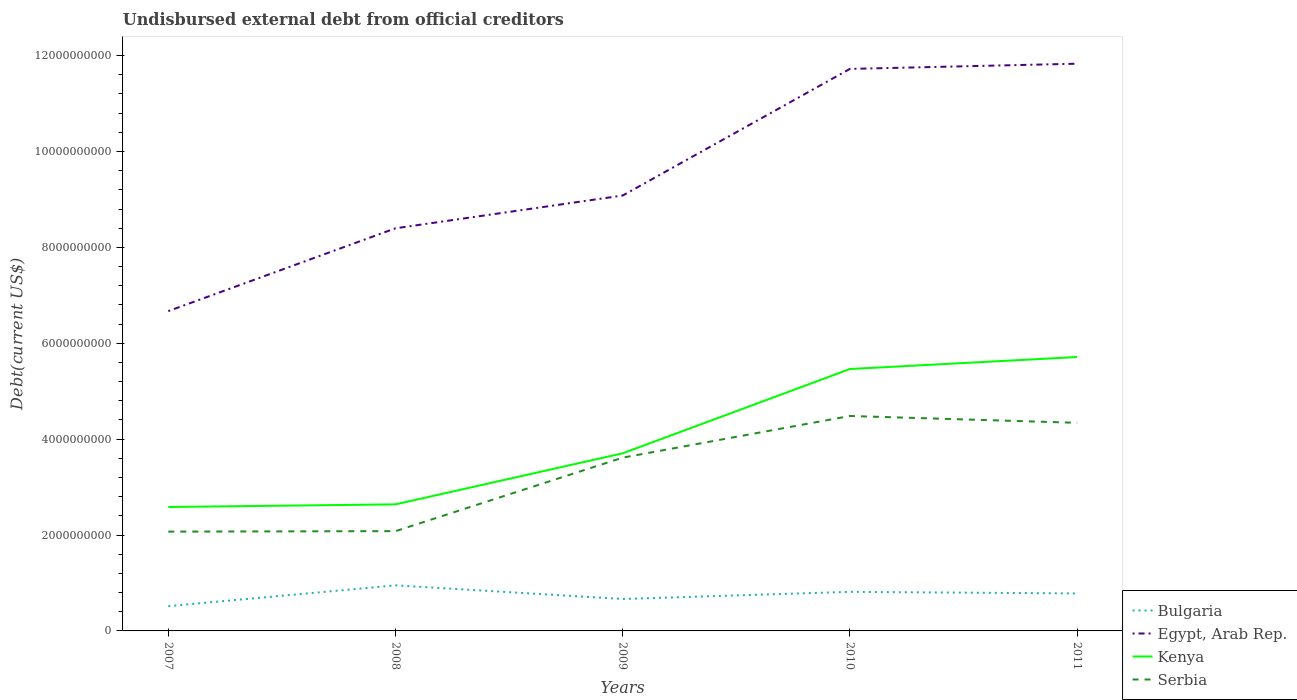Across all years, what is the maximum total debt in Egypt, Arab Rep.?
Keep it short and to the point. 6.67e+09. What is the total total debt in Bulgaria in the graph?
Keep it short and to the point. -2.65e+08. What is the difference between the highest and the second highest total debt in Bulgaria?
Offer a very short reply. 4.34e+08. How many lines are there?
Keep it short and to the point. 4. How many years are there in the graph?
Provide a succinct answer. 5. What is the difference between two consecutive major ticks on the Y-axis?
Provide a short and direct response. 2.00e+09. Does the graph contain grids?
Offer a very short reply. No. How many legend labels are there?
Make the answer very short. 4. What is the title of the graph?
Ensure brevity in your answer.  Undisbursed external debt from official creditors. Does "Afghanistan" appear as one of the legend labels in the graph?
Offer a terse response. No. What is the label or title of the X-axis?
Keep it short and to the point. Years. What is the label or title of the Y-axis?
Ensure brevity in your answer.  Debt(current US$). What is the Debt(current US$) of Bulgaria in 2007?
Give a very brief answer. 5.17e+08. What is the Debt(current US$) of Egypt, Arab Rep. in 2007?
Your answer should be very brief. 6.67e+09. What is the Debt(current US$) in Kenya in 2007?
Your answer should be compact. 2.58e+09. What is the Debt(current US$) in Serbia in 2007?
Make the answer very short. 2.07e+09. What is the Debt(current US$) in Bulgaria in 2008?
Your answer should be compact. 9.51e+08. What is the Debt(current US$) of Egypt, Arab Rep. in 2008?
Provide a short and direct response. 8.40e+09. What is the Debt(current US$) of Kenya in 2008?
Offer a very short reply. 2.64e+09. What is the Debt(current US$) in Serbia in 2008?
Ensure brevity in your answer.  2.08e+09. What is the Debt(current US$) of Bulgaria in 2009?
Provide a succinct answer. 6.66e+08. What is the Debt(current US$) in Egypt, Arab Rep. in 2009?
Ensure brevity in your answer.  9.08e+09. What is the Debt(current US$) of Kenya in 2009?
Keep it short and to the point. 3.70e+09. What is the Debt(current US$) in Serbia in 2009?
Offer a very short reply. 3.61e+09. What is the Debt(current US$) in Bulgaria in 2010?
Your answer should be very brief. 8.15e+08. What is the Debt(current US$) in Egypt, Arab Rep. in 2010?
Your answer should be compact. 1.17e+1. What is the Debt(current US$) in Kenya in 2010?
Your response must be concise. 5.46e+09. What is the Debt(current US$) of Serbia in 2010?
Ensure brevity in your answer.  4.48e+09. What is the Debt(current US$) in Bulgaria in 2011?
Make the answer very short. 7.82e+08. What is the Debt(current US$) of Egypt, Arab Rep. in 2011?
Give a very brief answer. 1.18e+1. What is the Debt(current US$) of Kenya in 2011?
Offer a very short reply. 5.71e+09. What is the Debt(current US$) in Serbia in 2011?
Your answer should be very brief. 4.34e+09. Across all years, what is the maximum Debt(current US$) of Bulgaria?
Offer a terse response. 9.51e+08. Across all years, what is the maximum Debt(current US$) in Egypt, Arab Rep.?
Your response must be concise. 1.18e+1. Across all years, what is the maximum Debt(current US$) in Kenya?
Your answer should be very brief. 5.71e+09. Across all years, what is the maximum Debt(current US$) of Serbia?
Give a very brief answer. 4.48e+09. Across all years, what is the minimum Debt(current US$) in Bulgaria?
Ensure brevity in your answer.  5.17e+08. Across all years, what is the minimum Debt(current US$) in Egypt, Arab Rep.?
Make the answer very short. 6.67e+09. Across all years, what is the minimum Debt(current US$) of Kenya?
Give a very brief answer. 2.58e+09. Across all years, what is the minimum Debt(current US$) in Serbia?
Give a very brief answer. 2.07e+09. What is the total Debt(current US$) in Bulgaria in the graph?
Provide a succinct answer. 3.73e+09. What is the total Debt(current US$) in Egypt, Arab Rep. in the graph?
Ensure brevity in your answer.  4.77e+1. What is the total Debt(current US$) of Kenya in the graph?
Your response must be concise. 2.01e+1. What is the total Debt(current US$) of Serbia in the graph?
Your answer should be compact. 1.66e+1. What is the difference between the Debt(current US$) of Bulgaria in 2007 and that in 2008?
Provide a succinct answer. -4.34e+08. What is the difference between the Debt(current US$) of Egypt, Arab Rep. in 2007 and that in 2008?
Ensure brevity in your answer.  -1.73e+09. What is the difference between the Debt(current US$) of Kenya in 2007 and that in 2008?
Provide a succinct answer. -5.50e+07. What is the difference between the Debt(current US$) in Serbia in 2007 and that in 2008?
Give a very brief answer. -1.02e+07. What is the difference between the Debt(current US$) of Bulgaria in 2007 and that in 2009?
Give a very brief answer. -1.49e+08. What is the difference between the Debt(current US$) in Egypt, Arab Rep. in 2007 and that in 2009?
Provide a short and direct response. -2.41e+09. What is the difference between the Debt(current US$) in Kenya in 2007 and that in 2009?
Keep it short and to the point. -1.12e+09. What is the difference between the Debt(current US$) in Serbia in 2007 and that in 2009?
Your answer should be compact. -1.54e+09. What is the difference between the Debt(current US$) in Bulgaria in 2007 and that in 2010?
Offer a terse response. -2.98e+08. What is the difference between the Debt(current US$) in Egypt, Arab Rep. in 2007 and that in 2010?
Keep it short and to the point. -5.05e+09. What is the difference between the Debt(current US$) of Kenya in 2007 and that in 2010?
Make the answer very short. -2.88e+09. What is the difference between the Debt(current US$) in Serbia in 2007 and that in 2010?
Offer a terse response. -2.41e+09. What is the difference between the Debt(current US$) in Bulgaria in 2007 and that in 2011?
Give a very brief answer. -2.65e+08. What is the difference between the Debt(current US$) in Egypt, Arab Rep. in 2007 and that in 2011?
Your answer should be compact. -5.16e+09. What is the difference between the Debt(current US$) of Kenya in 2007 and that in 2011?
Give a very brief answer. -3.13e+09. What is the difference between the Debt(current US$) in Serbia in 2007 and that in 2011?
Keep it short and to the point. -2.27e+09. What is the difference between the Debt(current US$) in Bulgaria in 2008 and that in 2009?
Provide a succinct answer. 2.84e+08. What is the difference between the Debt(current US$) in Egypt, Arab Rep. in 2008 and that in 2009?
Give a very brief answer. -6.83e+08. What is the difference between the Debt(current US$) of Kenya in 2008 and that in 2009?
Make the answer very short. -1.06e+09. What is the difference between the Debt(current US$) in Serbia in 2008 and that in 2009?
Provide a succinct answer. -1.53e+09. What is the difference between the Debt(current US$) of Bulgaria in 2008 and that in 2010?
Offer a terse response. 1.35e+08. What is the difference between the Debt(current US$) in Egypt, Arab Rep. in 2008 and that in 2010?
Your answer should be very brief. -3.32e+09. What is the difference between the Debt(current US$) in Kenya in 2008 and that in 2010?
Offer a terse response. -2.82e+09. What is the difference between the Debt(current US$) in Serbia in 2008 and that in 2010?
Your answer should be very brief. -2.40e+09. What is the difference between the Debt(current US$) in Bulgaria in 2008 and that in 2011?
Your answer should be compact. 1.69e+08. What is the difference between the Debt(current US$) of Egypt, Arab Rep. in 2008 and that in 2011?
Keep it short and to the point. -3.43e+09. What is the difference between the Debt(current US$) of Kenya in 2008 and that in 2011?
Ensure brevity in your answer.  -3.07e+09. What is the difference between the Debt(current US$) in Serbia in 2008 and that in 2011?
Ensure brevity in your answer.  -2.26e+09. What is the difference between the Debt(current US$) of Bulgaria in 2009 and that in 2010?
Offer a very short reply. -1.49e+08. What is the difference between the Debt(current US$) of Egypt, Arab Rep. in 2009 and that in 2010?
Offer a terse response. -2.64e+09. What is the difference between the Debt(current US$) in Kenya in 2009 and that in 2010?
Give a very brief answer. -1.76e+09. What is the difference between the Debt(current US$) in Serbia in 2009 and that in 2010?
Your answer should be compact. -8.69e+08. What is the difference between the Debt(current US$) of Bulgaria in 2009 and that in 2011?
Keep it short and to the point. -1.16e+08. What is the difference between the Debt(current US$) in Egypt, Arab Rep. in 2009 and that in 2011?
Make the answer very short. -2.75e+09. What is the difference between the Debt(current US$) of Kenya in 2009 and that in 2011?
Provide a short and direct response. -2.01e+09. What is the difference between the Debt(current US$) in Serbia in 2009 and that in 2011?
Your answer should be compact. -7.26e+08. What is the difference between the Debt(current US$) of Bulgaria in 2010 and that in 2011?
Your answer should be very brief. 3.32e+07. What is the difference between the Debt(current US$) of Egypt, Arab Rep. in 2010 and that in 2011?
Your answer should be very brief. -1.09e+08. What is the difference between the Debt(current US$) in Kenya in 2010 and that in 2011?
Offer a very short reply. -2.50e+08. What is the difference between the Debt(current US$) in Serbia in 2010 and that in 2011?
Your answer should be very brief. 1.43e+08. What is the difference between the Debt(current US$) of Bulgaria in 2007 and the Debt(current US$) of Egypt, Arab Rep. in 2008?
Offer a terse response. -7.88e+09. What is the difference between the Debt(current US$) of Bulgaria in 2007 and the Debt(current US$) of Kenya in 2008?
Your response must be concise. -2.12e+09. What is the difference between the Debt(current US$) of Bulgaria in 2007 and the Debt(current US$) of Serbia in 2008?
Your answer should be very brief. -1.56e+09. What is the difference between the Debt(current US$) of Egypt, Arab Rep. in 2007 and the Debt(current US$) of Kenya in 2008?
Your answer should be compact. 4.03e+09. What is the difference between the Debt(current US$) in Egypt, Arab Rep. in 2007 and the Debt(current US$) in Serbia in 2008?
Provide a short and direct response. 4.59e+09. What is the difference between the Debt(current US$) of Kenya in 2007 and the Debt(current US$) of Serbia in 2008?
Ensure brevity in your answer.  5.04e+08. What is the difference between the Debt(current US$) of Bulgaria in 2007 and the Debt(current US$) of Egypt, Arab Rep. in 2009?
Your answer should be compact. -8.57e+09. What is the difference between the Debt(current US$) in Bulgaria in 2007 and the Debt(current US$) in Kenya in 2009?
Provide a succinct answer. -3.19e+09. What is the difference between the Debt(current US$) of Bulgaria in 2007 and the Debt(current US$) of Serbia in 2009?
Ensure brevity in your answer.  -3.10e+09. What is the difference between the Debt(current US$) of Egypt, Arab Rep. in 2007 and the Debt(current US$) of Kenya in 2009?
Keep it short and to the point. 2.97e+09. What is the difference between the Debt(current US$) in Egypt, Arab Rep. in 2007 and the Debt(current US$) in Serbia in 2009?
Offer a terse response. 3.06e+09. What is the difference between the Debt(current US$) in Kenya in 2007 and the Debt(current US$) in Serbia in 2009?
Your answer should be very brief. -1.03e+09. What is the difference between the Debt(current US$) in Bulgaria in 2007 and the Debt(current US$) in Egypt, Arab Rep. in 2010?
Offer a terse response. -1.12e+1. What is the difference between the Debt(current US$) of Bulgaria in 2007 and the Debt(current US$) of Kenya in 2010?
Offer a very short reply. -4.95e+09. What is the difference between the Debt(current US$) in Bulgaria in 2007 and the Debt(current US$) in Serbia in 2010?
Make the answer very short. -3.97e+09. What is the difference between the Debt(current US$) in Egypt, Arab Rep. in 2007 and the Debt(current US$) in Kenya in 2010?
Offer a very short reply. 1.21e+09. What is the difference between the Debt(current US$) in Egypt, Arab Rep. in 2007 and the Debt(current US$) in Serbia in 2010?
Your response must be concise. 2.19e+09. What is the difference between the Debt(current US$) of Kenya in 2007 and the Debt(current US$) of Serbia in 2010?
Keep it short and to the point. -1.90e+09. What is the difference between the Debt(current US$) in Bulgaria in 2007 and the Debt(current US$) in Egypt, Arab Rep. in 2011?
Give a very brief answer. -1.13e+1. What is the difference between the Debt(current US$) of Bulgaria in 2007 and the Debt(current US$) of Kenya in 2011?
Offer a terse response. -5.20e+09. What is the difference between the Debt(current US$) of Bulgaria in 2007 and the Debt(current US$) of Serbia in 2011?
Keep it short and to the point. -3.82e+09. What is the difference between the Debt(current US$) of Egypt, Arab Rep. in 2007 and the Debt(current US$) of Kenya in 2011?
Your answer should be very brief. 9.58e+08. What is the difference between the Debt(current US$) in Egypt, Arab Rep. in 2007 and the Debt(current US$) in Serbia in 2011?
Give a very brief answer. 2.33e+09. What is the difference between the Debt(current US$) in Kenya in 2007 and the Debt(current US$) in Serbia in 2011?
Offer a very short reply. -1.76e+09. What is the difference between the Debt(current US$) of Bulgaria in 2008 and the Debt(current US$) of Egypt, Arab Rep. in 2009?
Your answer should be very brief. -8.13e+09. What is the difference between the Debt(current US$) of Bulgaria in 2008 and the Debt(current US$) of Kenya in 2009?
Provide a short and direct response. -2.75e+09. What is the difference between the Debt(current US$) of Bulgaria in 2008 and the Debt(current US$) of Serbia in 2009?
Your answer should be compact. -2.66e+09. What is the difference between the Debt(current US$) of Egypt, Arab Rep. in 2008 and the Debt(current US$) of Kenya in 2009?
Provide a succinct answer. 4.69e+09. What is the difference between the Debt(current US$) of Egypt, Arab Rep. in 2008 and the Debt(current US$) of Serbia in 2009?
Offer a very short reply. 4.78e+09. What is the difference between the Debt(current US$) in Kenya in 2008 and the Debt(current US$) in Serbia in 2009?
Provide a succinct answer. -9.75e+08. What is the difference between the Debt(current US$) of Bulgaria in 2008 and the Debt(current US$) of Egypt, Arab Rep. in 2010?
Provide a short and direct response. -1.08e+1. What is the difference between the Debt(current US$) of Bulgaria in 2008 and the Debt(current US$) of Kenya in 2010?
Offer a terse response. -4.51e+09. What is the difference between the Debt(current US$) in Bulgaria in 2008 and the Debt(current US$) in Serbia in 2010?
Keep it short and to the point. -3.53e+09. What is the difference between the Debt(current US$) in Egypt, Arab Rep. in 2008 and the Debt(current US$) in Kenya in 2010?
Keep it short and to the point. 2.94e+09. What is the difference between the Debt(current US$) in Egypt, Arab Rep. in 2008 and the Debt(current US$) in Serbia in 2010?
Keep it short and to the point. 3.91e+09. What is the difference between the Debt(current US$) in Kenya in 2008 and the Debt(current US$) in Serbia in 2010?
Make the answer very short. -1.84e+09. What is the difference between the Debt(current US$) in Bulgaria in 2008 and the Debt(current US$) in Egypt, Arab Rep. in 2011?
Provide a succinct answer. -1.09e+1. What is the difference between the Debt(current US$) of Bulgaria in 2008 and the Debt(current US$) of Kenya in 2011?
Give a very brief answer. -4.76e+09. What is the difference between the Debt(current US$) in Bulgaria in 2008 and the Debt(current US$) in Serbia in 2011?
Offer a very short reply. -3.39e+09. What is the difference between the Debt(current US$) in Egypt, Arab Rep. in 2008 and the Debt(current US$) in Kenya in 2011?
Offer a terse response. 2.69e+09. What is the difference between the Debt(current US$) of Egypt, Arab Rep. in 2008 and the Debt(current US$) of Serbia in 2011?
Make the answer very short. 4.06e+09. What is the difference between the Debt(current US$) of Kenya in 2008 and the Debt(current US$) of Serbia in 2011?
Your response must be concise. -1.70e+09. What is the difference between the Debt(current US$) of Bulgaria in 2009 and the Debt(current US$) of Egypt, Arab Rep. in 2010?
Give a very brief answer. -1.11e+1. What is the difference between the Debt(current US$) of Bulgaria in 2009 and the Debt(current US$) of Kenya in 2010?
Ensure brevity in your answer.  -4.80e+09. What is the difference between the Debt(current US$) in Bulgaria in 2009 and the Debt(current US$) in Serbia in 2010?
Ensure brevity in your answer.  -3.82e+09. What is the difference between the Debt(current US$) in Egypt, Arab Rep. in 2009 and the Debt(current US$) in Kenya in 2010?
Ensure brevity in your answer.  3.62e+09. What is the difference between the Debt(current US$) of Egypt, Arab Rep. in 2009 and the Debt(current US$) of Serbia in 2010?
Your answer should be compact. 4.60e+09. What is the difference between the Debt(current US$) in Kenya in 2009 and the Debt(current US$) in Serbia in 2010?
Offer a very short reply. -7.79e+08. What is the difference between the Debt(current US$) in Bulgaria in 2009 and the Debt(current US$) in Egypt, Arab Rep. in 2011?
Ensure brevity in your answer.  -1.12e+1. What is the difference between the Debt(current US$) of Bulgaria in 2009 and the Debt(current US$) of Kenya in 2011?
Your answer should be very brief. -5.05e+09. What is the difference between the Debt(current US$) in Bulgaria in 2009 and the Debt(current US$) in Serbia in 2011?
Keep it short and to the point. -3.67e+09. What is the difference between the Debt(current US$) of Egypt, Arab Rep. in 2009 and the Debt(current US$) of Kenya in 2011?
Keep it short and to the point. 3.37e+09. What is the difference between the Debt(current US$) in Egypt, Arab Rep. in 2009 and the Debt(current US$) in Serbia in 2011?
Provide a succinct answer. 4.74e+09. What is the difference between the Debt(current US$) in Kenya in 2009 and the Debt(current US$) in Serbia in 2011?
Make the answer very short. -6.36e+08. What is the difference between the Debt(current US$) of Bulgaria in 2010 and the Debt(current US$) of Egypt, Arab Rep. in 2011?
Offer a terse response. -1.10e+1. What is the difference between the Debt(current US$) in Bulgaria in 2010 and the Debt(current US$) in Kenya in 2011?
Make the answer very short. -4.90e+09. What is the difference between the Debt(current US$) in Bulgaria in 2010 and the Debt(current US$) in Serbia in 2011?
Ensure brevity in your answer.  -3.53e+09. What is the difference between the Debt(current US$) in Egypt, Arab Rep. in 2010 and the Debt(current US$) in Kenya in 2011?
Make the answer very short. 6.01e+09. What is the difference between the Debt(current US$) of Egypt, Arab Rep. in 2010 and the Debt(current US$) of Serbia in 2011?
Provide a short and direct response. 7.38e+09. What is the difference between the Debt(current US$) of Kenya in 2010 and the Debt(current US$) of Serbia in 2011?
Give a very brief answer. 1.12e+09. What is the average Debt(current US$) of Bulgaria per year?
Offer a very short reply. 7.46e+08. What is the average Debt(current US$) in Egypt, Arab Rep. per year?
Give a very brief answer. 9.54e+09. What is the average Debt(current US$) in Kenya per year?
Your answer should be very brief. 4.02e+09. What is the average Debt(current US$) in Serbia per year?
Offer a terse response. 3.32e+09. In the year 2007, what is the difference between the Debt(current US$) in Bulgaria and Debt(current US$) in Egypt, Arab Rep.?
Give a very brief answer. -6.15e+09. In the year 2007, what is the difference between the Debt(current US$) of Bulgaria and Debt(current US$) of Kenya?
Ensure brevity in your answer.  -2.07e+09. In the year 2007, what is the difference between the Debt(current US$) of Bulgaria and Debt(current US$) of Serbia?
Provide a short and direct response. -1.55e+09. In the year 2007, what is the difference between the Debt(current US$) of Egypt, Arab Rep. and Debt(current US$) of Kenya?
Offer a terse response. 4.09e+09. In the year 2007, what is the difference between the Debt(current US$) in Egypt, Arab Rep. and Debt(current US$) in Serbia?
Provide a short and direct response. 4.60e+09. In the year 2007, what is the difference between the Debt(current US$) in Kenya and Debt(current US$) in Serbia?
Offer a terse response. 5.14e+08. In the year 2008, what is the difference between the Debt(current US$) in Bulgaria and Debt(current US$) in Egypt, Arab Rep.?
Your response must be concise. -7.45e+09. In the year 2008, what is the difference between the Debt(current US$) of Bulgaria and Debt(current US$) of Kenya?
Provide a succinct answer. -1.69e+09. In the year 2008, what is the difference between the Debt(current US$) of Bulgaria and Debt(current US$) of Serbia?
Provide a succinct answer. -1.13e+09. In the year 2008, what is the difference between the Debt(current US$) in Egypt, Arab Rep. and Debt(current US$) in Kenya?
Your answer should be compact. 5.76e+09. In the year 2008, what is the difference between the Debt(current US$) in Egypt, Arab Rep. and Debt(current US$) in Serbia?
Your answer should be very brief. 6.32e+09. In the year 2008, what is the difference between the Debt(current US$) of Kenya and Debt(current US$) of Serbia?
Give a very brief answer. 5.59e+08. In the year 2009, what is the difference between the Debt(current US$) in Bulgaria and Debt(current US$) in Egypt, Arab Rep.?
Keep it short and to the point. -8.42e+09. In the year 2009, what is the difference between the Debt(current US$) in Bulgaria and Debt(current US$) in Kenya?
Your response must be concise. -3.04e+09. In the year 2009, what is the difference between the Debt(current US$) in Bulgaria and Debt(current US$) in Serbia?
Give a very brief answer. -2.95e+09. In the year 2009, what is the difference between the Debt(current US$) in Egypt, Arab Rep. and Debt(current US$) in Kenya?
Your answer should be very brief. 5.38e+09. In the year 2009, what is the difference between the Debt(current US$) in Egypt, Arab Rep. and Debt(current US$) in Serbia?
Keep it short and to the point. 5.47e+09. In the year 2009, what is the difference between the Debt(current US$) of Kenya and Debt(current US$) of Serbia?
Give a very brief answer. 9.02e+07. In the year 2010, what is the difference between the Debt(current US$) in Bulgaria and Debt(current US$) in Egypt, Arab Rep.?
Ensure brevity in your answer.  -1.09e+1. In the year 2010, what is the difference between the Debt(current US$) in Bulgaria and Debt(current US$) in Kenya?
Ensure brevity in your answer.  -4.65e+09. In the year 2010, what is the difference between the Debt(current US$) in Bulgaria and Debt(current US$) in Serbia?
Make the answer very short. -3.67e+09. In the year 2010, what is the difference between the Debt(current US$) of Egypt, Arab Rep. and Debt(current US$) of Kenya?
Your response must be concise. 6.26e+09. In the year 2010, what is the difference between the Debt(current US$) of Egypt, Arab Rep. and Debt(current US$) of Serbia?
Keep it short and to the point. 7.24e+09. In the year 2010, what is the difference between the Debt(current US$) in Kenya and Debt(current US$) in Serbia?
Provide a succinct answer. 9.80e+08. In the year 2011, what is the difference between the Debt(current US$) in Bulgaria and Debt(current US$) in Egypt, Arab Rep.?
Provide a succinct answer. -1.10e+1. In the year 2011, what is the difference between the Debt(current US$) of Bulgaria and Debt(current US$) of Kenya?
Your answer should be compact. -4.93e+09. In the year 2011, what is the difference between the Debt(current US$) of Bulgaria and Debt(current US$) of Serbia?
Your response must be concise. -3.56e+09. In the year 2011, what is the difference between the Debt(current US$) in Egypt, Arab Rep. and Debt(current US$) in Kenya?
Your answer should be very brief. 6.12e+09. In the year 2011, what is the difference between the Debt(current US$) in Egypt, Arab Rep. and Debt(current US$) in Serbia?
Your answer should be very brief. 7.49e+09. In the year 2011, what is the difference between the Debt(current US$) of Kenya and Debt(current US$) of Serbia?
Ensure brevity in your answer.  1.37e+09. What is the ratio of the Debt(current US$) of Bulgaria in 2007 to that in 2008?
Your answer should be very brief. 0.54. What is the ratio of the Debt(current US$) of Egypt, Arab Rep. in 2007 to that in 2008?
Keep it short and to the point. 0.79. What is the ratio of the Debt(current US$) in Kenya in 2007 to that in 2008?
Provide a succinct answer. 0.98. What is the ratio of the Debt(current US$) in Bulgaria in 2007 to that in 2009?
Offer a very short reply. 0.78. What is the ratio of the Debt(current US$) in Egypt, Arab Rep. in 2007 to that in 2009?
Keep it short and to the point. 0.73. What is the ratio of the Debt(current US$) of Kenya in 2007 to that in 2009?
Keep it short and to the point. 0.7. What is the ratio of the Debt(current US$) of Serbia in 2007 to that in 2009?
Provide a succinct answer. 0.57. What is the ratio of the Debt(current US$) in Bulgaria in 2007 to that in 2010?
Offer a very short reply. 0.63. What is the ratio of the Debt(current US$) of Egypt, Arab Rep. in 2007 to that in 2010?
Your response must be concise. 0.57. What is the ratio of the Debt(current US$) of Kenya in 2007 to that in 2010?
Your answer should be very brief. 0.47. What is the ratio of the Debt(current US$) of Serbia in 2007 to that in 2010?
Provide a succinct answer. 0.46. What is the ratio of the Debt(current US$) of Bulgaria in 2007 to that in 2011?
Ensure brevity in your answer.  0.66. What is the ratio of the Debt(current US$) in Egypt, Arab Rep. in 2007 to that in 2011?
Make the answer very short. 0.56. What is the ratio of the Debt(current US$) of Kenya in 2007 to that in 2011?
Your answer should be compact. 0.45. What is the ratio of the Debt(current US$) in Serbia in 2007 to that in 2011?
Give a very brief answer. 0.48. What is the ratio of the Debt(current US$) in Bulgaria in 2008 to that in 2009?
Your answer should be very brief. 1.43. What is the ratio of the Debt(current US$) of Egypt, Arab Rep. in 2008 to that in 2009?
Provide a short and direct response. 0.92. What is the ratio of the Debt(current US$) of Kenya in 2008 to that in 2009?
Your answer should be compact. 0.71. What is the ratio of the Debt(current US$) of Serbia in 2008 to that in 2009?
Ensure brevity in your answer.  0.58. What is the ratio of the Debt(current US$) of Bulgaria in 2008 to that in 2010?
Offer a very short reply. 1.17. What is the ratio of the Debt(current US$) in Egypt, Arab Rep. in 2008 to that in 2010?
Your response must be concise. 0.72. What is the ratio of the Debt(current US$) in Kenya in 2008 to that in 2010?
Your answer should be very brief. 0.48. What is the ratio of the Debt(current US$) of Serbia in 2008 to that in 2010?
Your answer should be compact. 0.46. What is the ratio of the Debt(current US$) in Bulgaria in 2008 to that in 2011?
Keep it short and to the point. 1.22. What is the ratio of the Debt(current US$) in Egypt, Arab Rep. in 2008 to that in 2011?
Offer a very short reply. 0.71. What is the ratio of the Debt(current US$) in Kenya in 2008 to that in 2011?
Your response must be concise. 0.46. What is the ratio of the Debt(current US$) in Serbia in 2008 to that in 2011?
Ensure brevity in your answer.  0.48. What is the ratio of the Debt(current US$) of Bulgaria in 2009 to that in 2010?
Offer a very short reply. 0.82. What is the ratio of the Debt(current US$) in Egypt, Arab Rep. in 2009 to that in 2010?
Give a very brief answer. 0.77. What is the ratio of the Debt(current US$) in Kenya in 2009 to that in 2010?
Make the answer very short. 0.68. What is the ratio of the Debt(current US$) in Serbia in 2009 to that in 2010?
Offer a very short reply. 0.81. What is the ratio of the Debt(current US$) of Bulgaria in 2009 to that in 2011?
Keep it short and to the point. 0.85. What is the ratio of the Debt(current US$) of Egypt, Arab Rep. in 2009 to that in 2011?
Keep it short and to the point. 0.77. What is the ratio of the Debt(current US$) in Kenya in 2009 to that in 2011?
Your answer should be very brief. 0.65. What is the ratio of the Debt(current US$) of Serbia in 2009 to that in 2011?
Provide a short and direct response. 0.83. What is the ratio of the Debt(current US$) of Bulgaria in 2010 to that in 2011?
Provide a succinct answer. 1.04. What is the ratio of the Debt(current US$) of Kenya in 2010 to that in 2011?
Your response must be concise. 0.96. What is the ratio of the Debt(current US$) of Serbia in 2010 to that in 2011?
Offer a terse response. 1.03. What is the difference between the highest and the second highest Debt(current US$) in Bulgaria?
Provide a succinct answer. 1.35e+08. What is the difference between the highest and the second highest Debt(current US$) in Egypt, Arab Rep.?
Offer a very short reply. 1.09e+08. What is the difference between the highest and the second highest Debt(current US$) in Kenya?
Provide a short and direct response. 2.50e+08. What is the difference between the highest and the second highest Debt(current US$) in Serbia?
Offer a terse response. 1.43e+08. What is the difference between the highest and the lowest Debt(current US$) of Bulgaria?
Your response must be concise. 4.34e+08. What is the difference between the highest and the lowest Debt(current US$) of Egypt, Arab Rep.?
Provide a succinct answer. 5.16e+09. What is the difference between the highest and the lowest Debt(current US$) of Kenya?
Your answer should be compact. 3.13e+09. What is the difference between the highest and the lowest Debt(current US$) in Serbia?
Your answer should be very brief. 2.41e+09. 